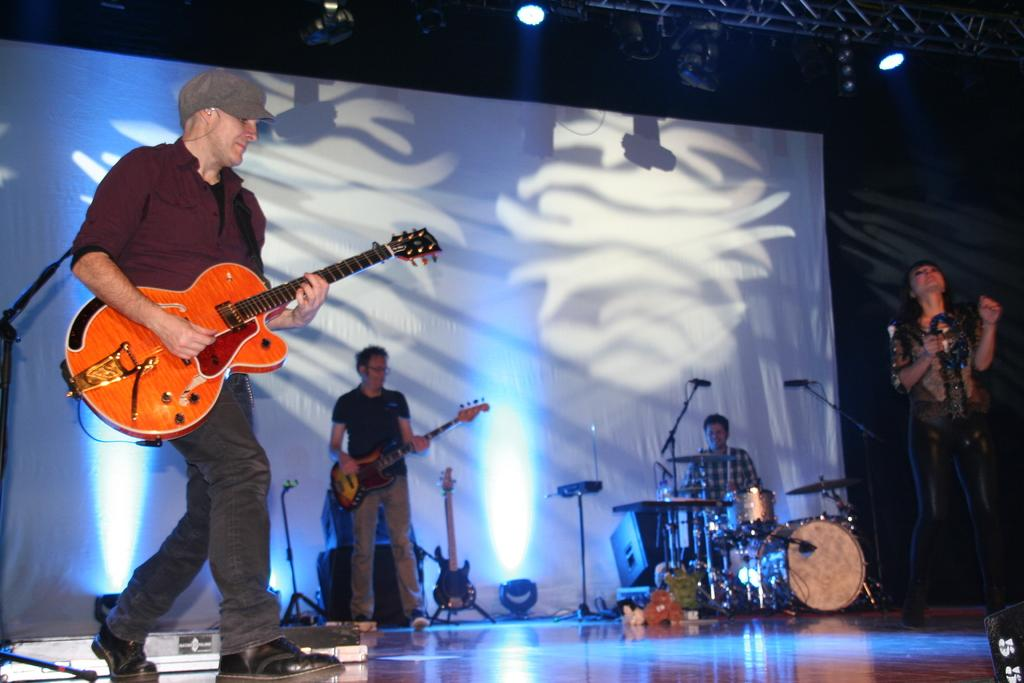How many people are on stage in the image? There are four persons on stage in the image. What are two of the persons doing on stage? Two of the persons are playing guitar. What is the third person doing on stage? One person is playing drums. What is the woman on stage doing? A woman is singing on a microphone. What can be seen in the background of the image? Cloth and lights are visible in the background. Can you hear the woman crying on the microphone in the image? There is no indication in the image that the woman is crying; she is singing on a microphone. 